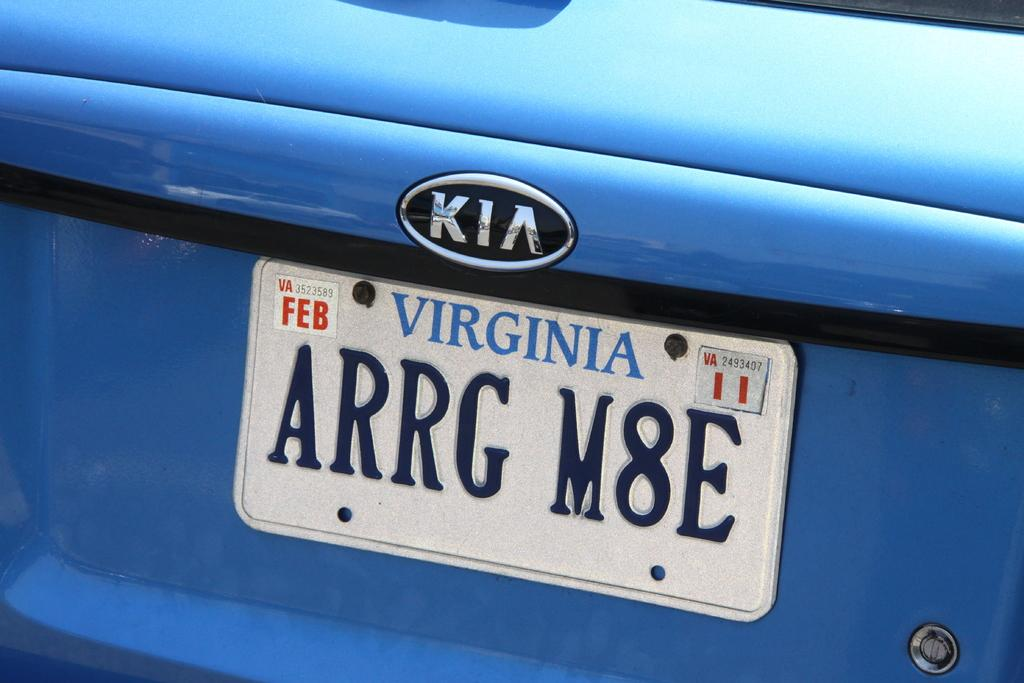<image>
Relay a brief, clear account of the picture shown. The back of a blue Kia from Virginia with a humorous license plate 